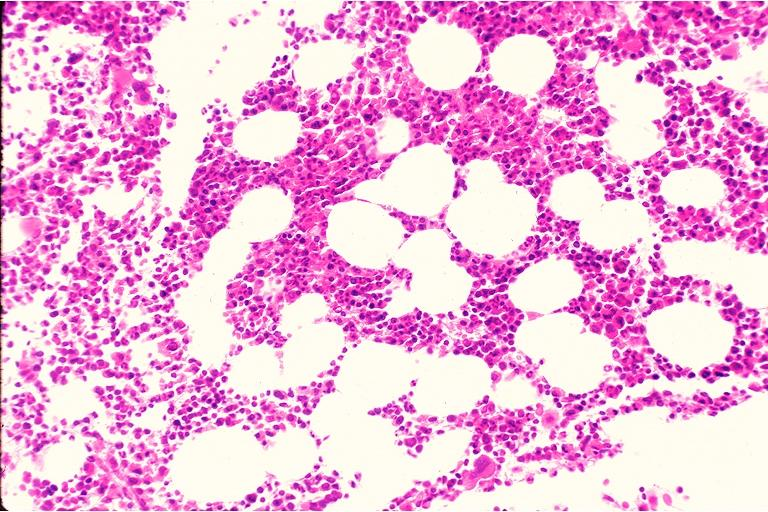does this image show hematopoietic bone marrow defect?
Answer the question using a single word or phrase. Yes 